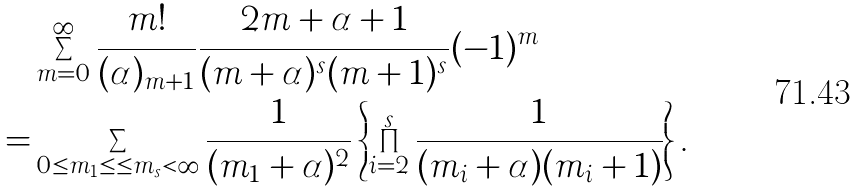Convert formula to latex. <formula><loc_0><loc_0><loc_500><loc_500>& \sum _ { m = 0 } ^ { \infty } \frac { m ! } { ( \alpha ) _ { m + 1 } } \frac { 2 m + \alpha + 1 } { ( m + \alpha ) ^ { s } ( m + 1 ) ^ { s } } ( - 1 ) ^ { m } \\ = & \sum _ { 0 \leq m _ { 1 } \leq \cdots { \leq } m _ { s } < \infty } \frac { 1 } { ( m _ { 1 } + \alpha ) ^ { 2 } } \left \{ \prod _ { i = 2 } ^ { s } \frac { 1 } { ( m _ { i } + \alpha ) ( m _ { i } + 1 ) } \right \} .</formula> 